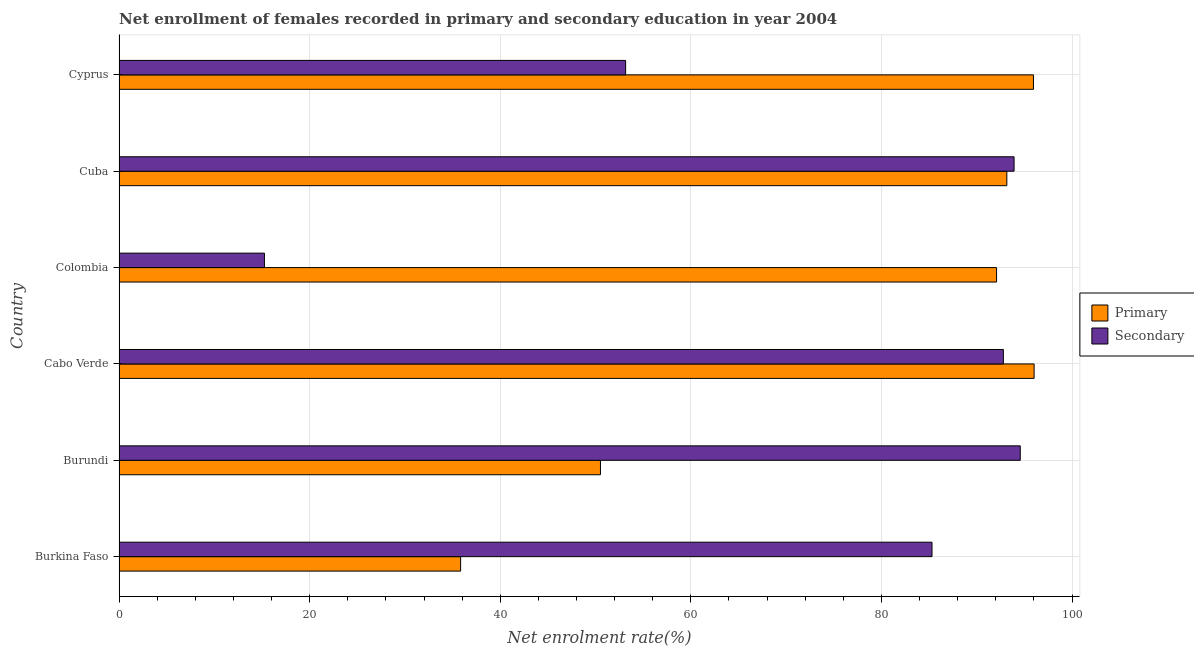How many different coloured bars are there?
Make the answer very short. 2. How many groups of bars are there?
Provide a short and direct response. 6. Are the number of bars on each tick of the Y-axis equal?
Offer a terse response. Yes. How many bars are there on the 3rd tick from the bottom?
Ensure brevity in your answer.  2. What is the label of the 2nd group of bars from the top?
Offer a terse response. Cuba. What is the enrollment rate in secondary education in Colombia?
Provide a short and direct response. 15.26. Across all countries, what is the maximum enrollment rate in secondary education?
Offer a terse response. 94.57. Across all countries, what is the minimum enrollment rate in secondary education?
Your response must be concise. 15.26. In which country was the enrollment rate in primary education maximum?
Your answer should be compact. Cabo Verde. In which country was the enrollment rate in primary education minimum?
Ensure brevity in your answer.  Burkina Faso. What is the total enrollment rate in primary education in the graph?
Your answer should be compact. 463.57. What is the difference between the enrollment rate in primary education in Cuba and that in Cyprus?
Provide a succinct answer. -2.79. What is the difference between the enrollment rate in primary education in Colombia and the enrollment rate in secondary education in Cabo Verde?
Offer a terse response. -0.71. What is the average enrollment rate in primary education per country?
Your response must be concise. 77.26. What is the difference between the enrollment rate in secondary education and enrollment rate in primary education in Colombia?
Your answer should be compact. -76.83. In how many countries, is the enrollment rate in secondary education greater than 76 %?
Ensure brevity in your answer.  4. What is the ratio of the enrollment rate in primary education in Cabo Verde to that in Cuba?
Provide a succinct answer. 1.03. What is the difference between the highest and the second highest enrollment rate in primary education?
Provide a succinct answer. 0.07. What is the difference between the highest and the lowest enrollment rate in secondary education?
Offer a terse response. 79.31. Is the sum of the enrollment rate in primary education in Colombia and Cyprus greater than the maximum enrollment rate in secondary education across all countries?
Provide a succinct answer. Yes. What does the 1st bar from the top in Cabo Verde represents?
Provide a succinct answer. Secondary. What does the 1st bar from the bottom in Cabo Verde represents?
Provide a succinct answer. Primary. Are all the bars in the graph horizontal?
Ensure brevity in your answer.  Yes. How many countries are there in the graph?
Your response must be concise. 6. What is the difference between two consecutive major ticks on the X-axis?
Offer a terse response. 20. Does the graph contain any zero values?
Your answer should be compact. No. Does the graph contain grids?
Make the answer very short. Yes. How are the legend labels stacked?
Your answer should be compact. Vertical. What is the title of the graph?
Make the answer very short. Net enrollment of females recorded in primary and secondary education in year 2004. What is the label or title of the X-axis?
Offer a terse response. Net enrolment rate(%). What is the label or title of the Y-axis?
Offer a terse response. Country. What is the Net enrolment rate(%) in Primary in Burkina Faso?
Offer a terse response. 35.84. What is the Net enrolment rate(%) in Secondary in Burkina Faso?
Make the answer very short. 85.31. What is the Net enrolment rate(%) in Primary in Burundi?
Your response must be concise. 50.52. What is the Net enrolment rate(%) of Secondary in Burundi?
Provide a succinct answer. 94.57. What is the Net enrolment rate(%) of Primary in Cabo Verde?
Offer a very short reply. 96.02. What is the Net enrolment rate(%) in Secondary in Cabo Verde?
Provide a short and direct response. 92.8. What is the Net enrolment rate(%) in Primary in Colombia?
Give a very brief answer. 92.08. What is the Net enrolment rate(%) of Secondary in Colombia?
Offer a terse response. 15.26. What is the Net enrolment rate(%) in Primary in Cuba?
Provide a succinct answer. 93.16. What is the Net enrolment rate(%) in Secondary in Cuba?
Offer a very short reply. 93.92. What is the Net enrolment rate(%) of Primary in Cyprus?
Your answer should be compact. 95.95. What is the Net enrolment rate(%) of Secondary in Cyprus?
Your response must be concise. 53.16. Across all countries, what is the maximum Net enrolment rate(%) of Primary?
Provide a short and direct response. 96.02. Across all countries, what is the maximum Net enrolment rate(%) of Secondary?
Provide a short and direct response. 94.57. Across all countries, what is the minimum Net enrolment rate(%) in Primary?
Provide a short and direct response. 35.84. Across all countries, what is the minimum Net enrolment rate(%) of Secondary?
Your answer should be very brief. 15.26. What is the total Net enrolment rate(%) of Primary in the graph?
Offer a terse response. 463.57. What is the total Net enrolment rate(%) of Secondary in the graph?
Keep it short and to the point. 435. What is the difference between the Net enrolment rate(%) of Primary in Burkina Faso and that in Burundi?
Make the answer very short. -14.67. What is the difference between the Net enrolment rate(%) of Secondary in Burkina Faso and that in Burundi?
Offer a terse response. -9.26. What is the difference between the Net enrolment rate(%) in Primary in Burkina Faso and that in Cabo Verde?
Your answer should be very brief. -60.18. What is the difference between the Net enrolment rate(%) in Secondary in Burkina Faso and that in Cabo Verde?
Your answer should be very brief. -7.49. What is the difference between the Net enrolment rate(%) of Primary in Burkina Faso and that in Colombia?
Your answer should be compact. -56.24. What is the difference between the Net enrolment rate(%) in Secondary in Burkina Faso and that in Colombia?
Provide a short and direct response. 70.05. What is the difference between the Net enrolment rate(%) of Primary in Burkina Faso and that in Cuba?
Offer a very short reply. -57.32. What is the difference between the Net enrolment rate(%) of Secondary in Burkina Faso and that in Cuba?
Offer a terse response. -8.61. What is the difference between the Net enrolment rate(%) in Primary in Burkina Faso and that in Cyprus?
Provide a succinct answer. -60.11. What is the difference between the Net enrolment rate(%) of Secondary in Burkina Faso and that in Cyprus?
Your answer should be compact. 32.15. What is the difference between the Net enrolment rate(%) of Primary in Burundi and that in Cabo Verde?
Provide a succinct answer. -45.51. What is the difference between the Net enrolment rate(%) of Secondary in Burundi and that in Cabo Verde?
Offer a terse response. 1.77. What is the difference between the Net enrolment rate(%) of Primary in Burundi and that in Colombia?
Give a very brief answer. -41.57. What is the difference between the Net enrolment rate(%) of Secondary in Burundi and that in Colombia?
Your answer should be very brief. 79.31. What is the difference between the Net enrolment rate(%) of Primary in Burundi and that in Cuba?
Your answer should be compact. -42.64. What is the difference between the Net enrolment rate(%) of Secondary in Burundi and that in Cuba?
Keep it short and to the point. 0.65. What is the difference between the Net enrolment rate(%) in Primary in Burundi and that in Cyprus?
Offer a very short reply. -45.44. What is the difference between the Net enrolment rate(%) in Secondary in Burundi and that in Cyprus?
Provide a short and direct response. 41.41. What is the difference between the Net enrolment rate(%) of Primary in Cabo Verde and that in Colombia?
Ensure brevity in your answer.  3.94. What is the difference between the Net enrolment rate(%) in Secondary in Cabo Verde and that in Colombia?
Ensure brevity in your answer.  77.54. What is the difference between the Net enrolment rate(%) of Primary in Cabo Verde and that in Cuba?
Provide a short and direct response. 2.86. What is the difference between the Net enrolment rate(%) of Secondary in Cabo Verde and that in Cuba?
Offer a terse response. -1.12. What is the difference between the Net enrolment rate(%) in Primary in Cabo Verde and that in Cyprus?
Your response must be concise. 0.07. What is the difference between the Net enrolment rate(%) of Secondary in Cabo Verde and that in Cyprus?
Offer a terse response. 39.64. What is the difference between the Net enrolment rate(%) of Primary in Colombia and that in Cuba?
Your answer should be compact. -1.08. What is the difference between the Net enrolment rate(%) of Secondary in Colombia and that in Cuba?
Your answer should be very brief. -78.66. What is the difference between the Net enrolment rate(%) in Primary in Colombia and that in Cyprus?
Provide a succinct answer. -3.87. What is the difference between the Net enrolment rate(%) of Secondary in Colombia and that in Cyprus?
Provide a short and direct response. -37.9. What is the difference between the Net enrolment rate(%) in Primary in Cuba and that in Cyprus?
Provide a short and direct response. -2.79. What is the difference between the Net enrolment rate(%) in Secondary in Cuba and that in Cyprus?
Make the answer very short. 40.76. What is the difference between the Net enrolment rate(%) of Primary in Burkina Faso and the Net enrolment rate(%) of Secondary in Burundi?
Offer a terse response. -58.73. What is the difference between the Net enrolment rate(%) in Primary in Burkina Faso and the Net enrolment rate(%) in Secondary in Cabo Verde?
Offer a terse response. -56.95. What is the difference between the Net enrolment rate(%) in Primary in Burkina Faso and the Net enrolment rate(%) in Secondary in Colombia?
Offer a very short reply. 20.59. What is the difference between the Net enrolment rate(%) of Primary in Burkina Faso and the Net enrolment rate(%) of Secondary in Cuba?
Offer a terse response. -58.08. What is the difference between the Net enrolment rate(%) in Primary in Burkina Faso and the Net enrolment rate(%) in Secondary in Cyprus?
Your response must be concise. -17.32. What is the difference between the Net enrolment rate(%) in Primary in Burundi and the Net enrolment rate(%) in Secondary in Cabo Verde?
Offer a very short reply. -42.28. What is the difference between the Net enrolment rate(%) in Primary in Burundi and the Net enrolment rate(%) in Secondary in Colombia?
Offer a very short reply. 35.26. What is the difference between the Net enrolment rate(%) of Primary in Burundi and the Net enrolment rate(%) of Secondary in Cuba?
Make the answer very short. -43.4. What is the difference between the Net enrolment rate(%) in Primary in Burundi and the Net enrolment rate(%) in Secondary in Cyprus?
Your response must be concise. -2.64. What is the difference between the Net enrolment rate(%) of Primary in Cabo Verde and the Net enrolment rate(%) of Secondary in Colombia?
Offer a terse response. 80.77. What is the difference between the Net enrolment rate(%) in Primary in Cabo Verde and the Net enrolment rate(%) in Secondary in Cuba?
Ensure brevity in your answer.  2.1. What is the difference between the Net enrolment rate(%) of Primary in Cabo Verde and the Net enrolment rate(%) of Secondary in Cyprus?
Keep it short and to the point. 42.87. What is the difference between the Net enrolment rate(%) of Primary in Colombia and the Net enrolment rate(%) of Secondary in Cuba?
Provide a short and direct response. -1.84. What is the difference between the Net enrolment rate(%) in Primary in Colombia and the Net enrolment rate(%) in Secondary in Cyprus?
Your answer should be very brief. 38.93. What is the difference between the Net enrolment rate(%) of Primary in Cuba and the Net enrolment rate(%) of Secondary in Cyprus?
Make the answer very short. 40. What is the average Net enrolment rate(%) of Primary per country?
Your answer should be compact. 77.26. What is the average Net enrolment rate(%) in Secondary per country?
Your answer should be compact. 72.5. What is the difference between the Net enrolment rate(%) in Primary and Net enrolment rate(%) in Secondary in Burkina Faso?
Ensure brevity in your answer.  -49.47. What is the difference between the Net enrolment rate(%) in Primary and Net enrolment rate(%) in Secondary in Burundi?
Provide a short and direct response. -44.05. What is the difference between the Net enrolment rate(%) in Primary and Net enrolment rate(%) in Secondary in Cabo Verde?
Offer a terse response. 3.23. What is the difference between the Net enrolment rate(%) of Primary and Net enrolment rate(%) of Secondary in Colombia?
Your response must be concise. 76.83. What is the difference between the Net enrolment rate(%) in Primary and Net enrolment rate(%) in Secondary in Cuba?
Provide a short and direct response. -0.76. What is the difference between the Net enrolment rate(%) of Primary and Net enrolment rate(%) of Secondary in Cyprus?
Your answer should be compact. 42.8. What is the ratio of the Net enrolment rate(%) in Primary in Burkina Faso to that in Burundi?
Offer a terse response. 0.71. What is the ratio of the Net enrolment rate(%) in Secondary in Burkina Faso to that in Burundi?
Give a very brief answer. 0.9. What is the ratio of the Net enrolment rate(%) in Primary in Burkina Faso to that in Cabo Verde?
Offer a very short reply. 0.37. What is the ratio of the Net enrolment rate(%) of Secondary in Burkina Faso to that in Cabo Verde?
Offer a terse response. 0.92. What is the ratio of the Net enrolment rate(%) of Primary in Burkina Faso to that in Colombia?
Make the answer very short. 0.39. What is the ratio of the Net enrolment rate(%) of Secondary in Burkina Faso to that in Colombia?
Keep it short and to the point. 5.59. What is the ratio of the Net enrolment rate(%) of Primary in Burkina Faso to that in Cuba?
Offer a terse response. 0.38. What is the ratio of the Net enrolment rate(%) in Secondary in Burkina Faso to that in Cuba?
Ensure brevity in your answer.  0.91. What is the ratio of the Net enrolment rate(%) in Primary in Burkina Faso to that in Cyprus?
Make the answer very short. 0.37. What is the ratio of the Net enrolment rate(%) in Secondary in Burkina Faso to that in Cyprus?
Offer a very short reply. 1.6. What is the ratio of the Net enrolment rate(%) in Primary in Burundi to that in Cabo Verde?
Provide a succinct answer. 0.53. What is the ratio of the Net enrolment rate(%) of Secondary in Burundi to that in Cabo Verde?
Offer a very short reply. 1.02. What is the ratio of the Net enrolment rate(%) of Primary in Burundi to that in Colombia?
Provide a succinct answer. 0.55. What is the ratio of the Net enrolment rate(%) in Secondary in Burundi to that in Colombia?
Offer a terse response. 6.2. What is the ratio of the Net enrolment rate(%) in Primary in Burundi to that in Cuba?
Give a very brief answer. 0.54. What is the ratio of the Net enrolment rate(%) in Secondary in Burundi to that in Cuba?
Keep it short and to the point. 1.01. What is the ratio of the Net enrolment rate(%) in Primary in Burundi to that in Cyprus?
Ensure brevity in your answer.  0.53. What is the ratio of the Net enrolment rate(%) of Secondary in Burundi to that in Cyprus?
Offer a very short reply. 1.78. What is the ratio of the Net enrolment rate(%) in Primary in Cabo Verde to that in Colombia?
Keep it short and to the point. 1.04. What is the ratio of the Net enrolment rate(%) in Secondary in Cabo Verde to that in Colombia?
Provide a succinct answer. 6.08. What is the ratio of the Net enrolment rate(%) of Primary in Cabo Verde to that in Cuba?
Ensure brevity in your answer.  1.03. What is the ratio of the Net enrolment rate(%) in Secondary in Cabo Verde to that in Cyprus?
Offer a very short reply. 1.75. What is the ratio of the Net enrolment rate(%) in Primary in Colombia to that in Cuba?
Offer a terse response. 0.99. What is the ratio of the Net enrolment rate(%) in Secondary in Colombia to that in Cuba?
Give a very brief answer. 0.16. What is the ratio of the Net enrolment rate(%) of Primary in Colombia to that in Cyprus?
Make the answer very short. 0.96. What is the ratio of the Net enrolment rate(%) of Secondary in Colombia to that in Cyprus?
Give a very brief answer. 0.29. What is the ratio of the Net enrolment rate(%) of Primary in Cuba to that in Cyprus?
Offer a very short reply. 0.97. What is the ratio of the Net enrolment rate(%) in Secondary in Cuba to that in Cyprus?
Provide a short and direct response. 1.77. What is the difference between the highest and the second highest Net enrolment rate(%) in Primary?
Ensure brevity in your answer.  0.07. What is the difference between the highest and the second highest Net enrolment rate(%) in Secondary?
Your response must be concise. 0.65. What is the difference between the highest and the lowest Net enrolment rate(%) of Primary?
Your answer should be compact. 60.18. What is the difference between the highest and the lowest Net enrolment rate(%) in Secondary?
Provide a short and direct response. 79.31. 